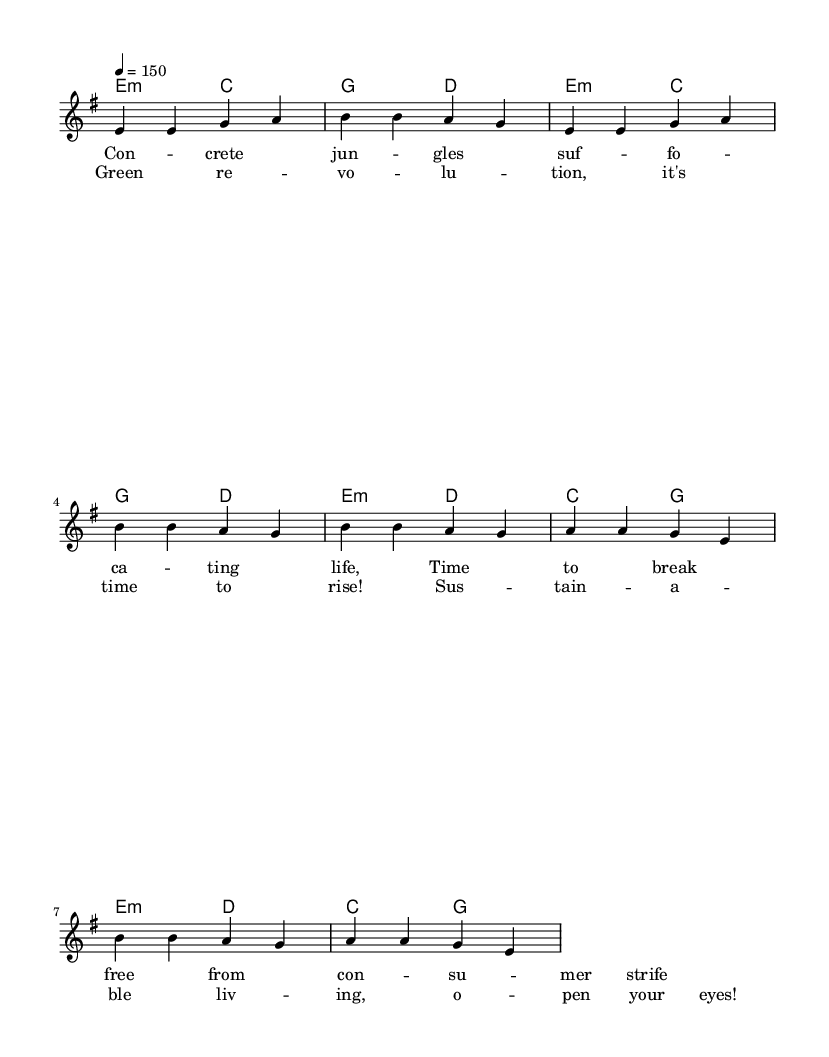What is the key signature of this music? The key signature is E minor, which has one sharp (F#). This can be identified by looking at the key signature at the beginning of the staff.
Answer: E minor What is the time signature of this music? The time signature is 4/4, indicated at the beginning of the score. This means there are four beats per measure and the quarter note receives one beat.
Answer: 4/4 What is the tempo marking of this piece? The tempo marking is 150 beats per minute, shown in the score next to the tempo indication. This indicates how fast the piece should be played.
Answer: 150 How many measures are in the verse section? The verse section consists of four measures, as counted from the first note to the end of the verse lyrics.
Answer: 4 How many different chords are used during the chorus? There are three different chords used in the chorus: E minor, D major, and C major. This can be determined by looking at the chord symbols above the melody during the chorus section.
Answer: 3 What is the main theme of the lyrics in this piece? The main theme of the lyrics is about environmental awareness and sustainable living, as indicated by phrases like "Green revolution" and "Sustainable living." This reflects the song’s overarching message.
Answer: Environmental awareness 